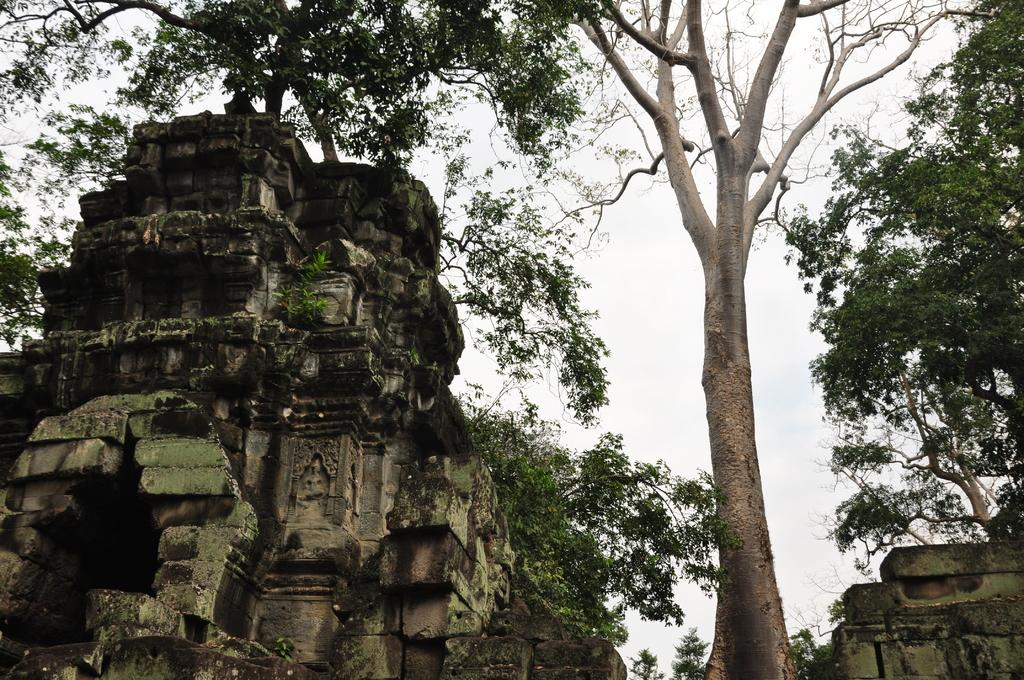What is the main structure in the image? There is a monument in the image. What type of vegetation can be seen in the image? There are plants and trees in the image. What is visible in the background of the image? The sky is visible in the image. How would you describe the weather based on the sky in the image? The sky appears to be cloudy in the image. What year is the monument's approval date in the image? There is no information about the monument's approval date in the image. 